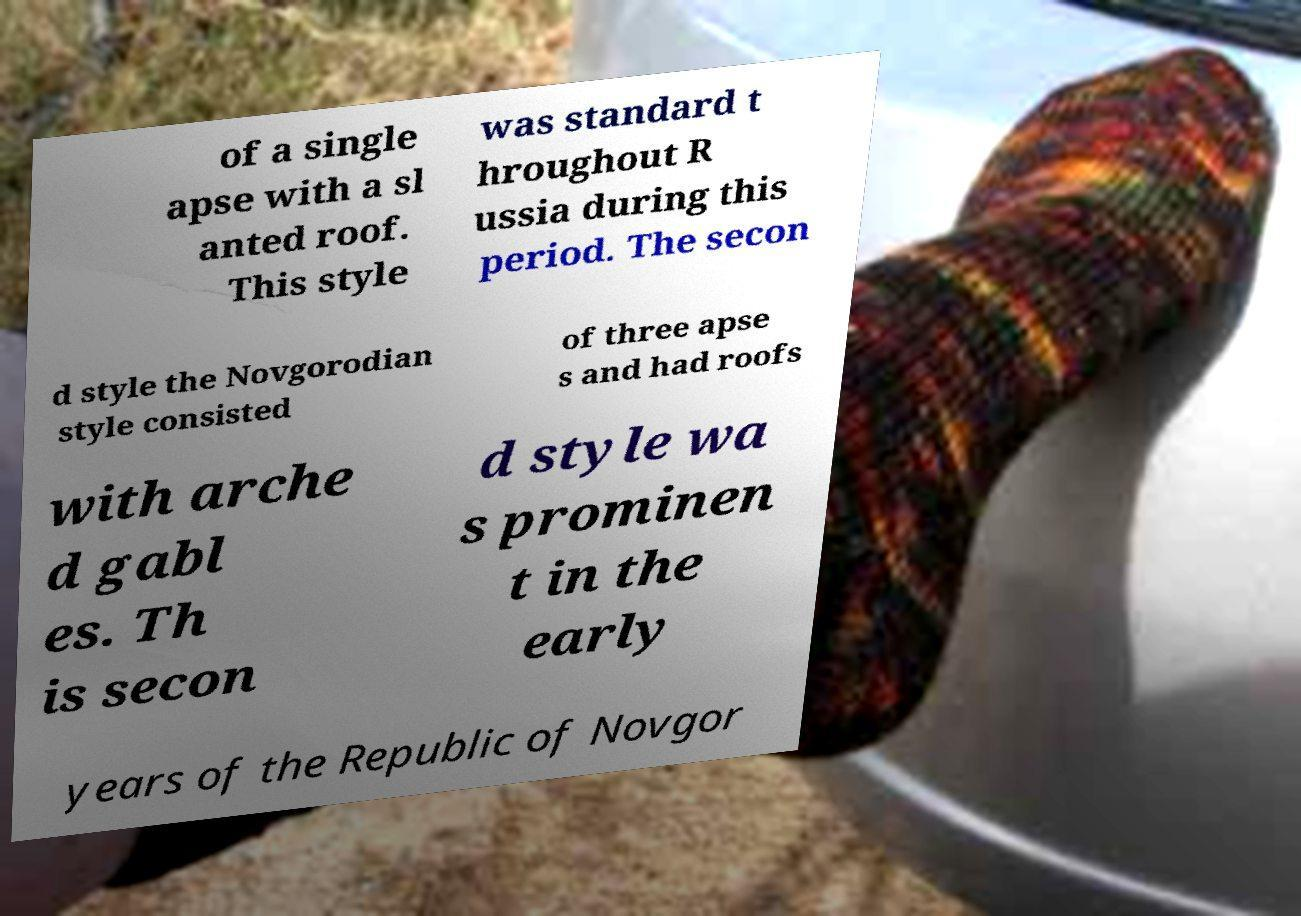Please read and relay the text visible in this image. What does it say? of a single apse with a sl anted roof. This style was standard t hroughout R ussia during this period. The secon d style the Novgorodian style consisted of three apse s and had roofs with arche d gabl es. Th is secon d style wa s prominen t in the early years of the Republic of Novgor 